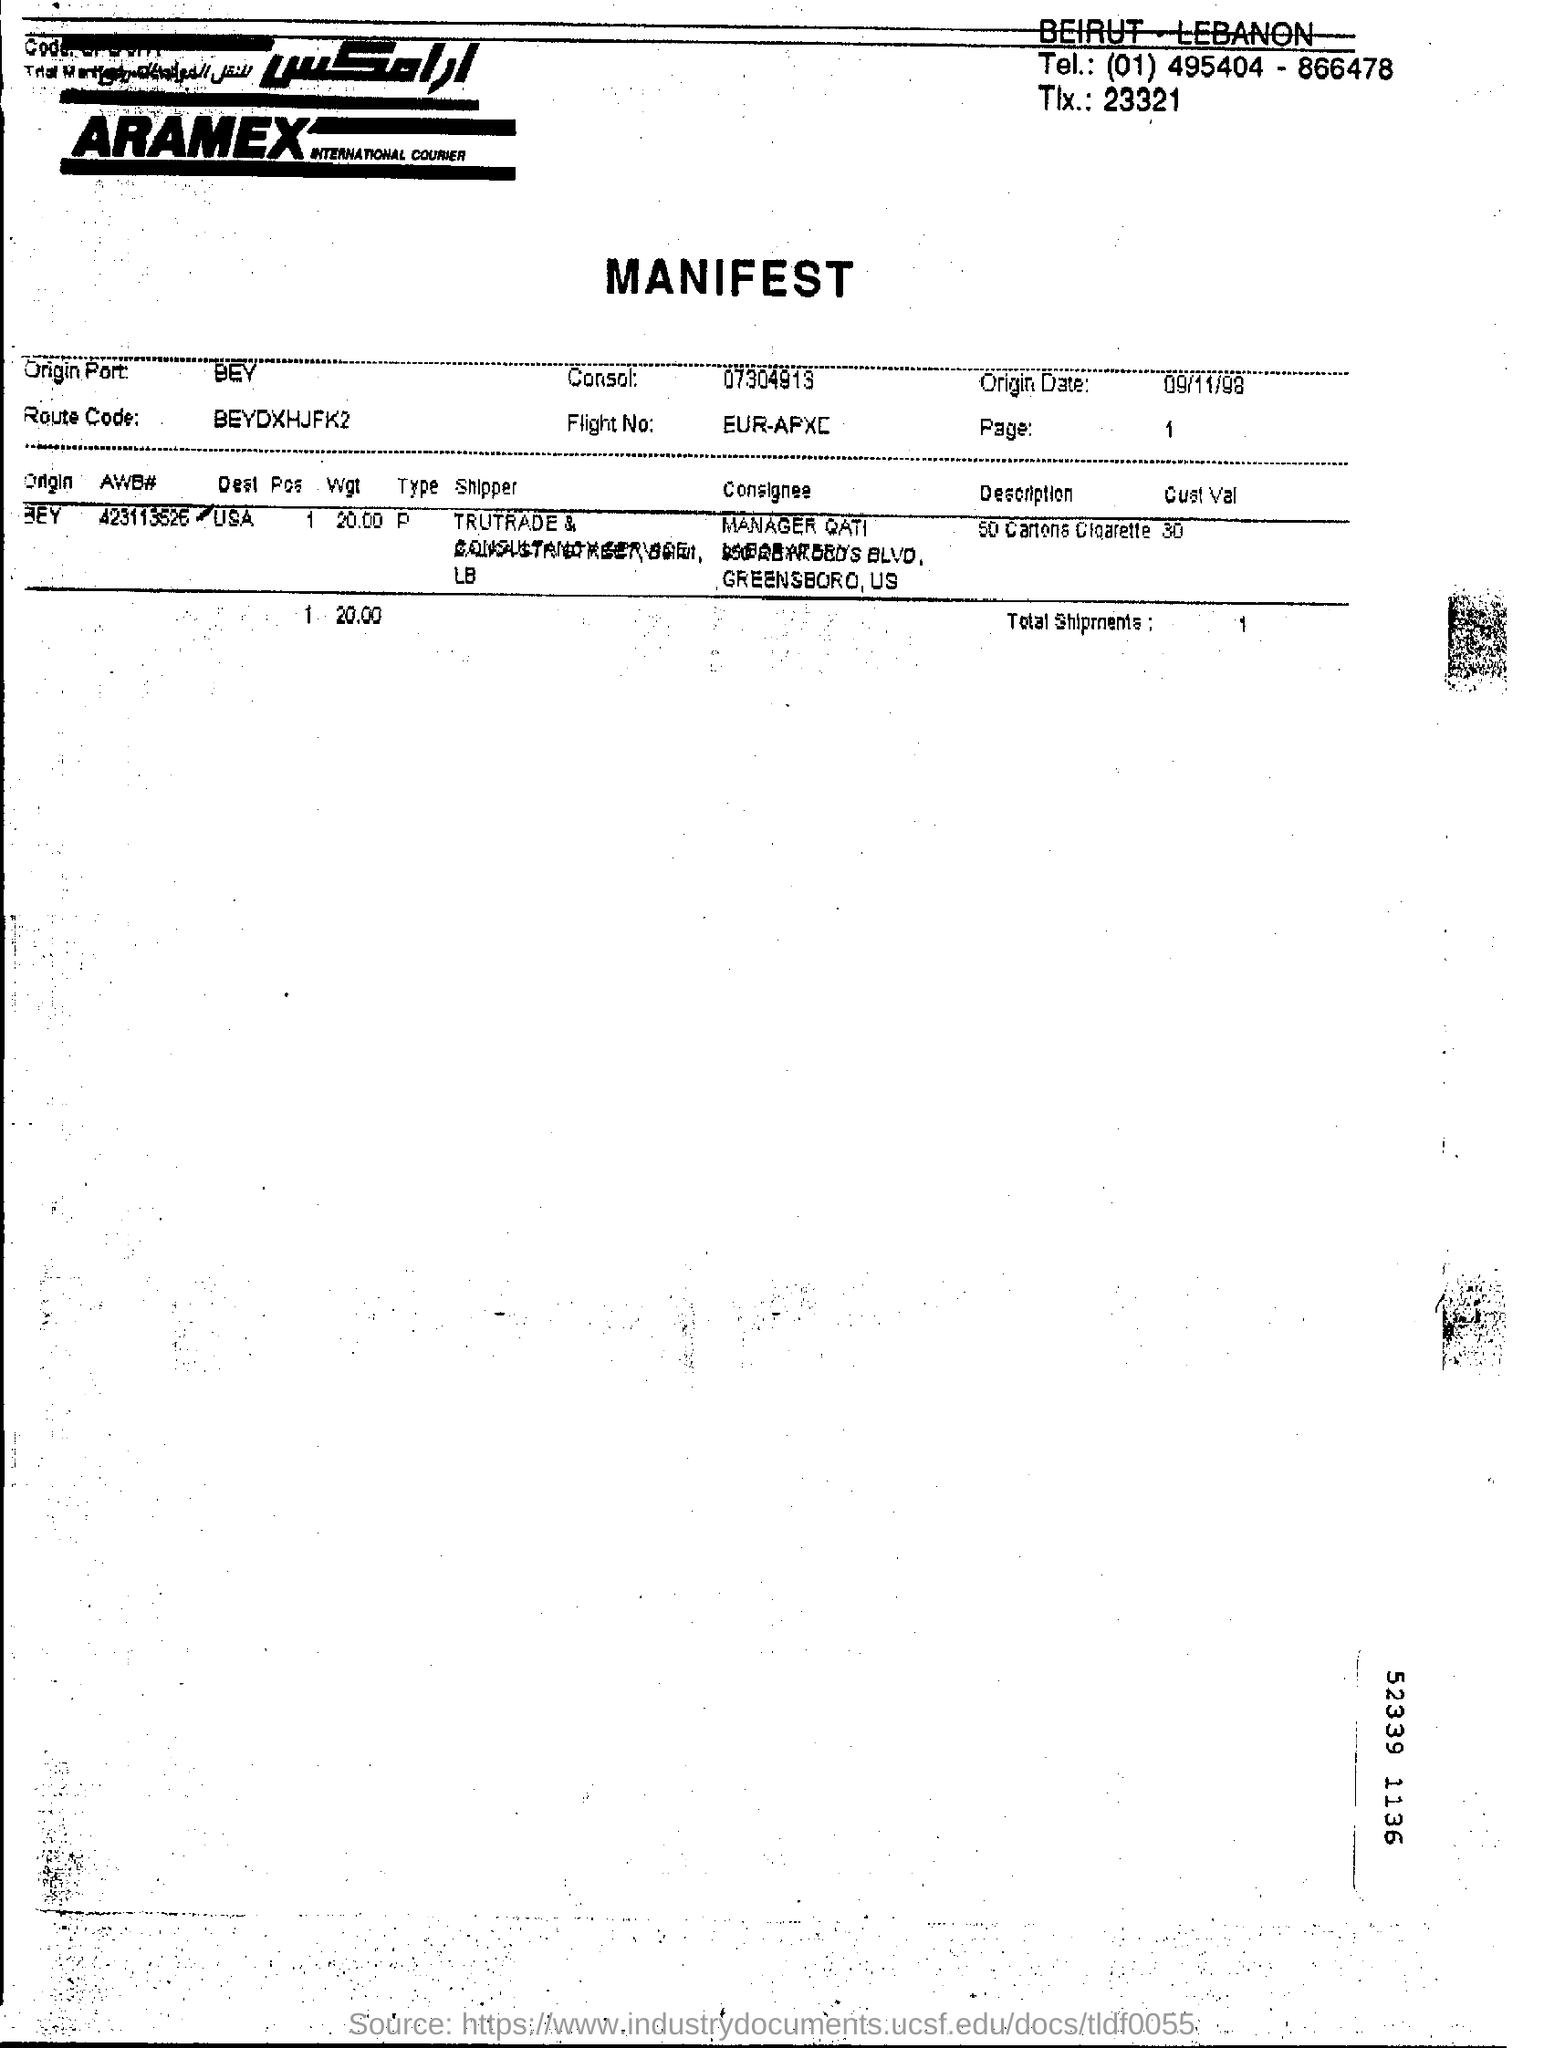What is origin date?
Your answer should be very brief. 09/11/98. What is the route code?
Provide a short and direct response. BEYDXHJFK2. 